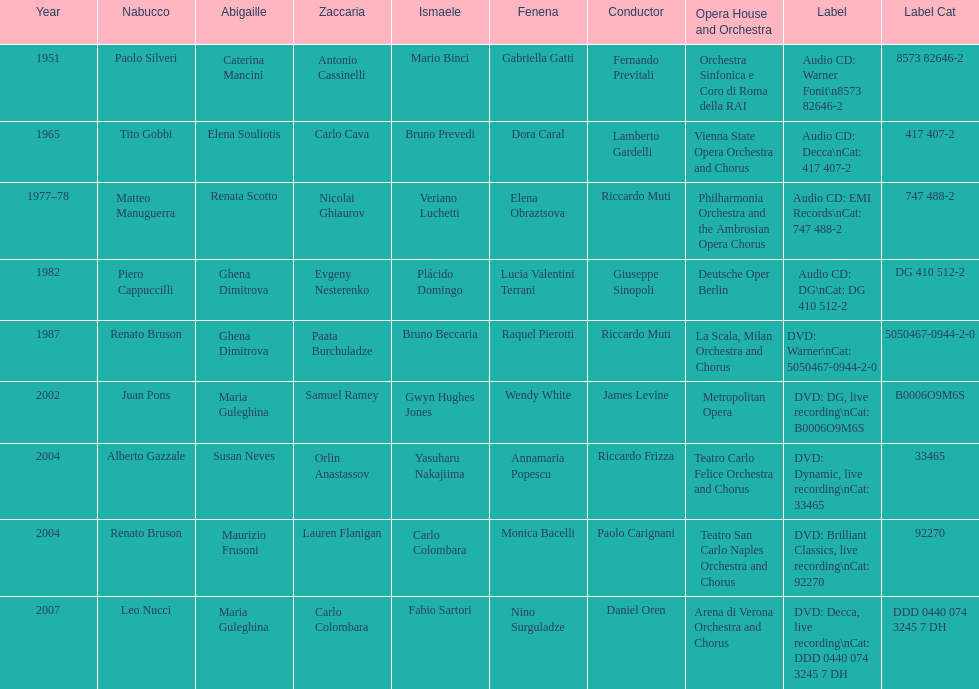How many recordings of nabucco have been made? 9. 